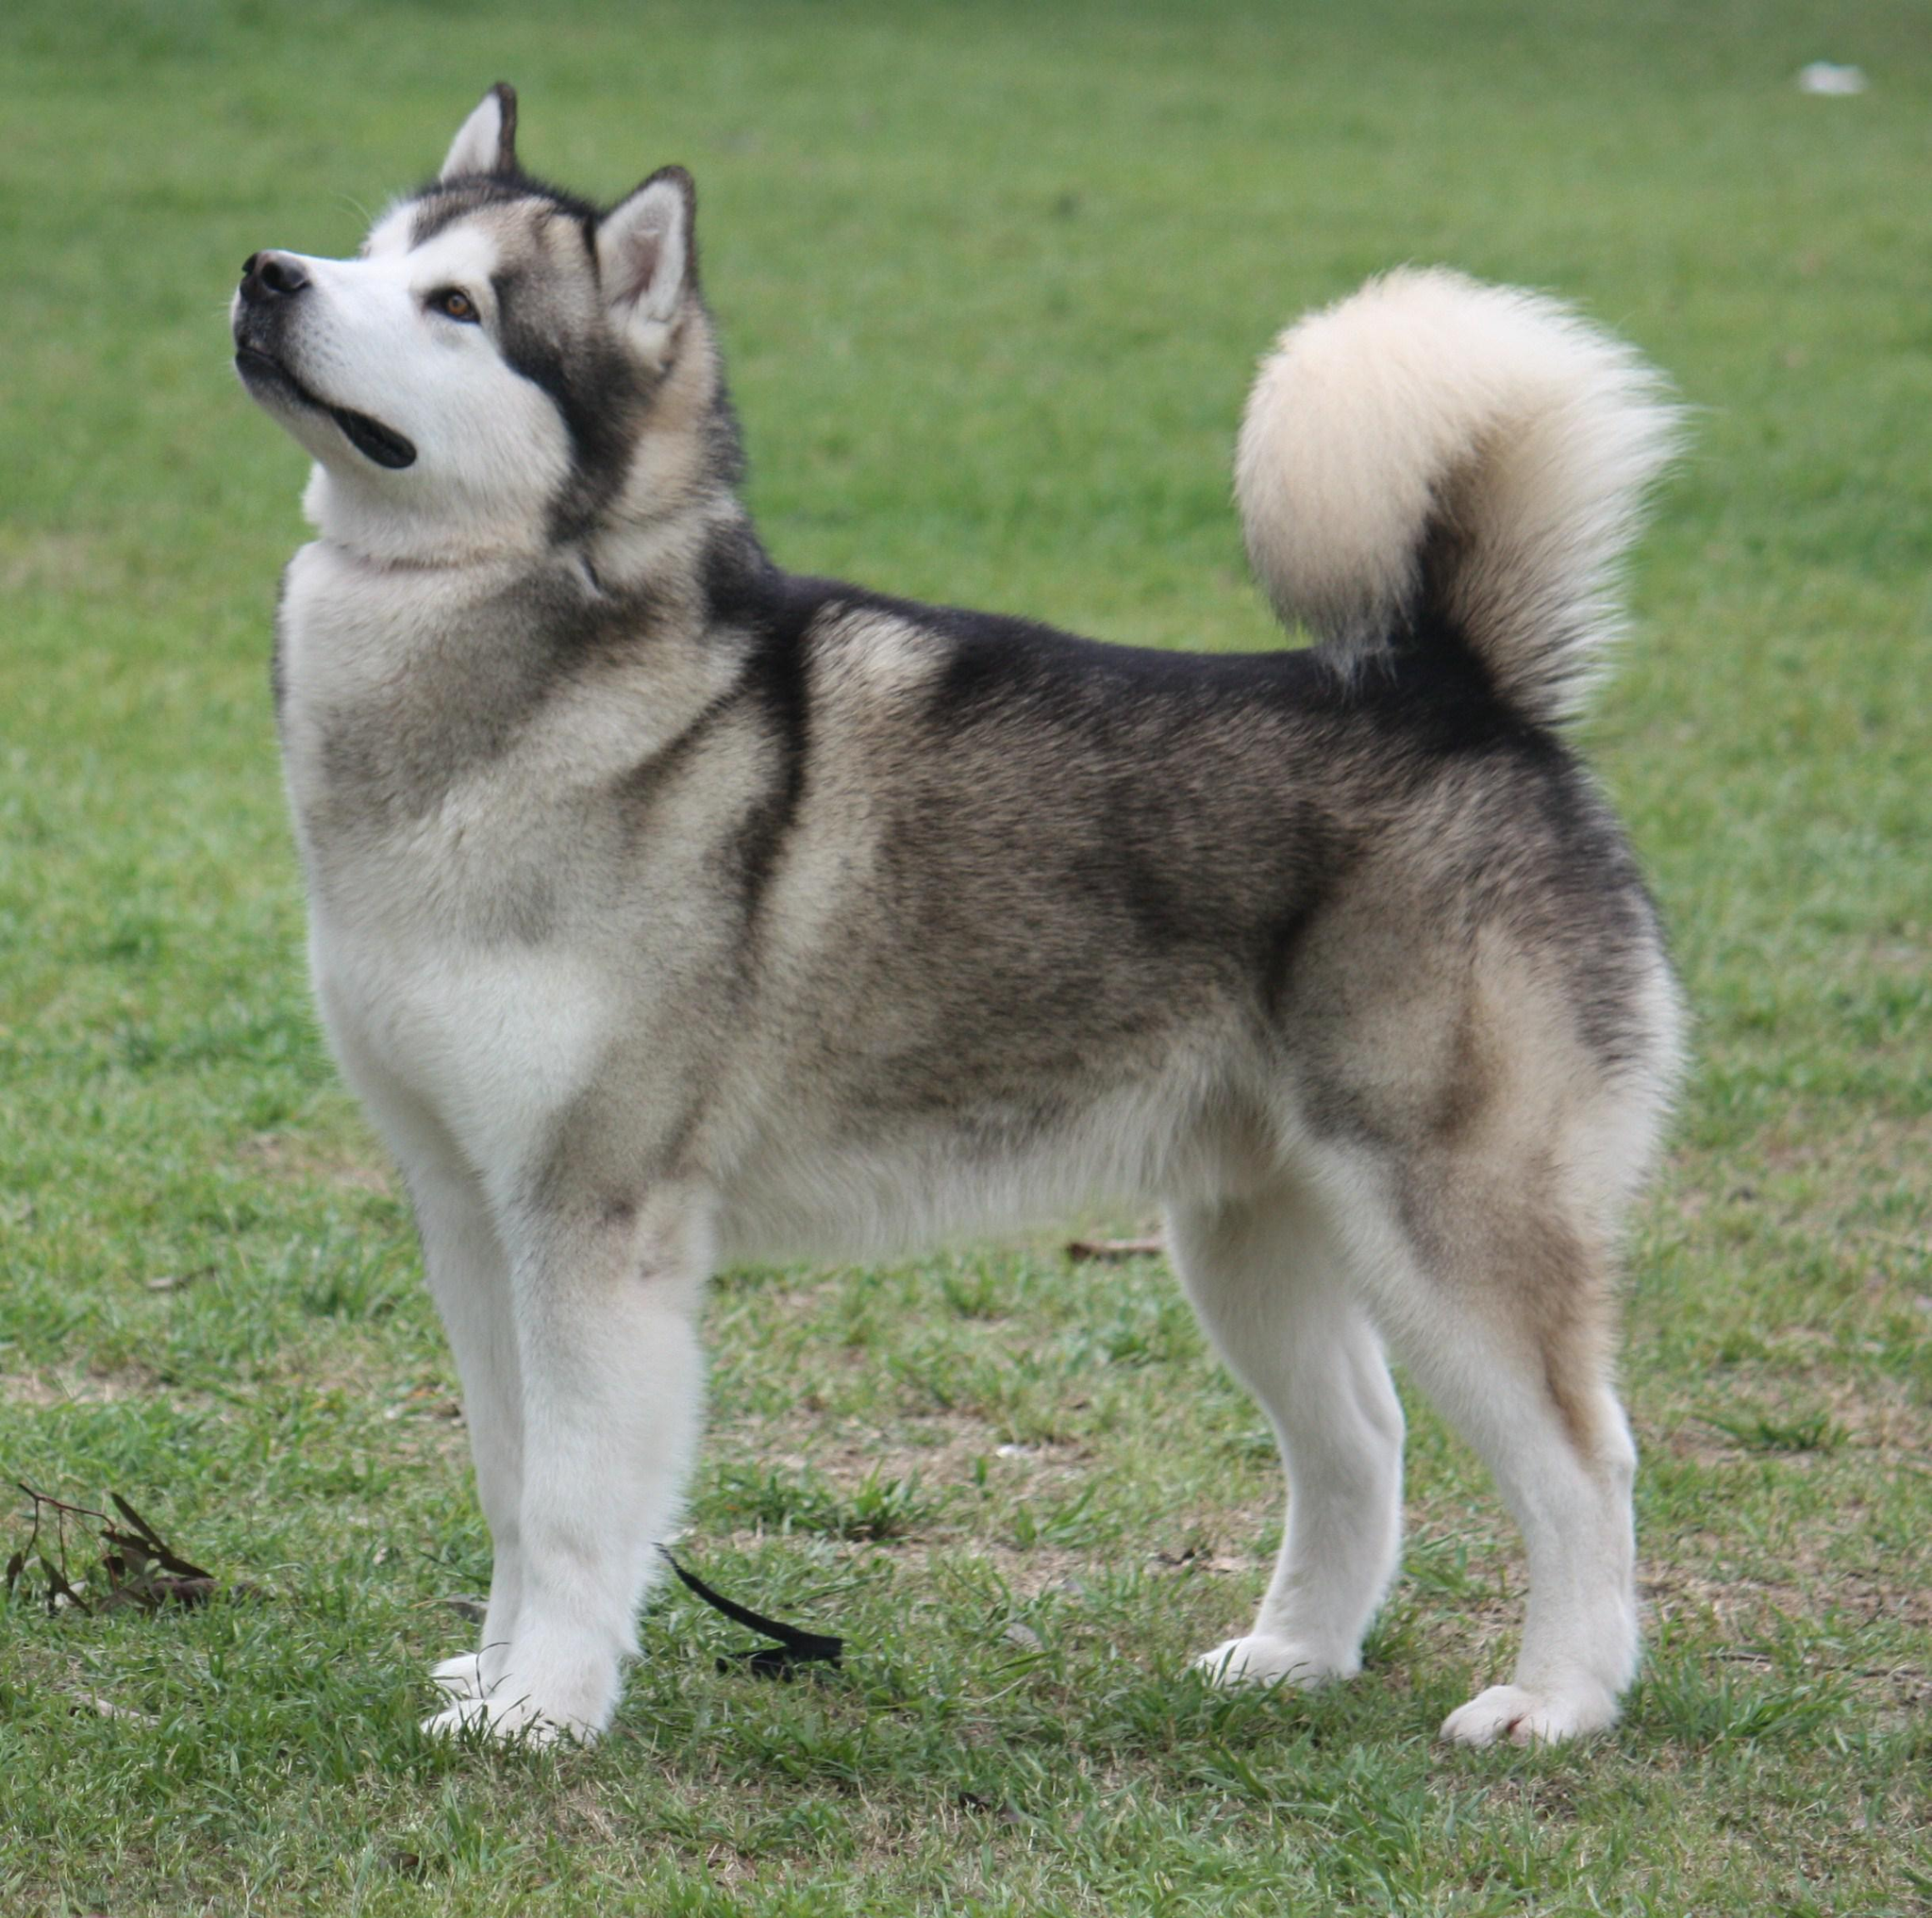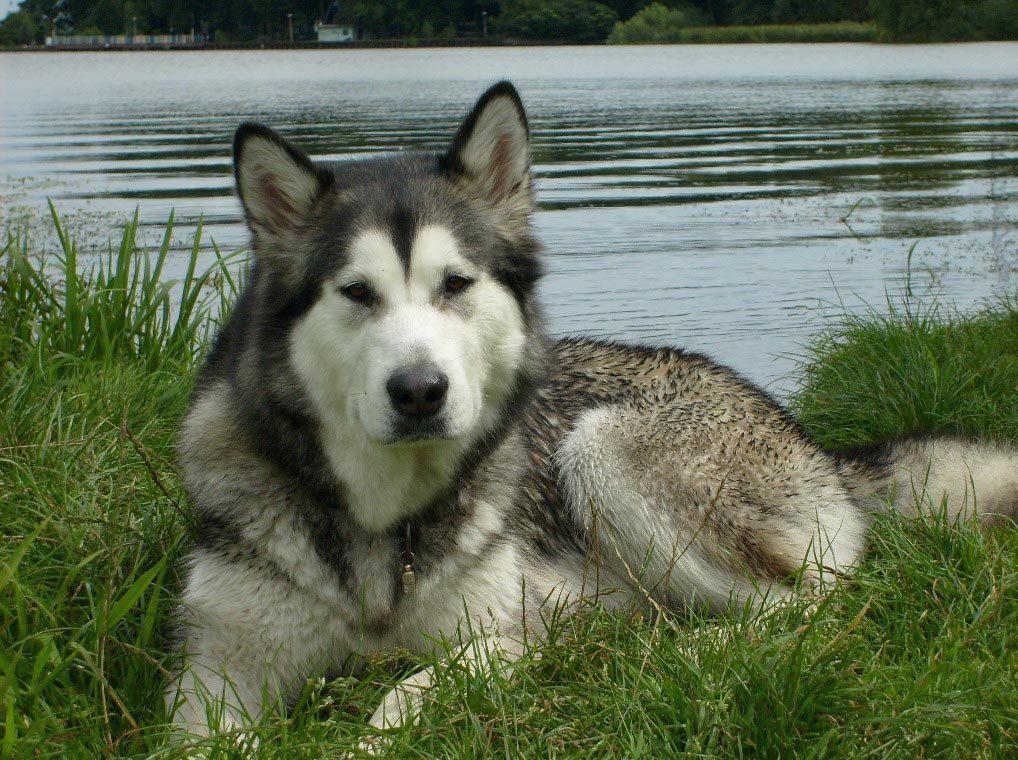The first image is the image on the left, the second image is the image on the right. Analyze the images presented: Is the assertion "Each image contains one adult husky, and one of the dogs pictured stands on all fours with its mouth open and tongue hanging out." valid? Answer yes or no. No. The first image is the image on the left, the second image is the image on the right. Assess this claim about the two images: "The dog in the image on the left is standing in the grass.". Correct or not? Answer yes or no. Yes. 